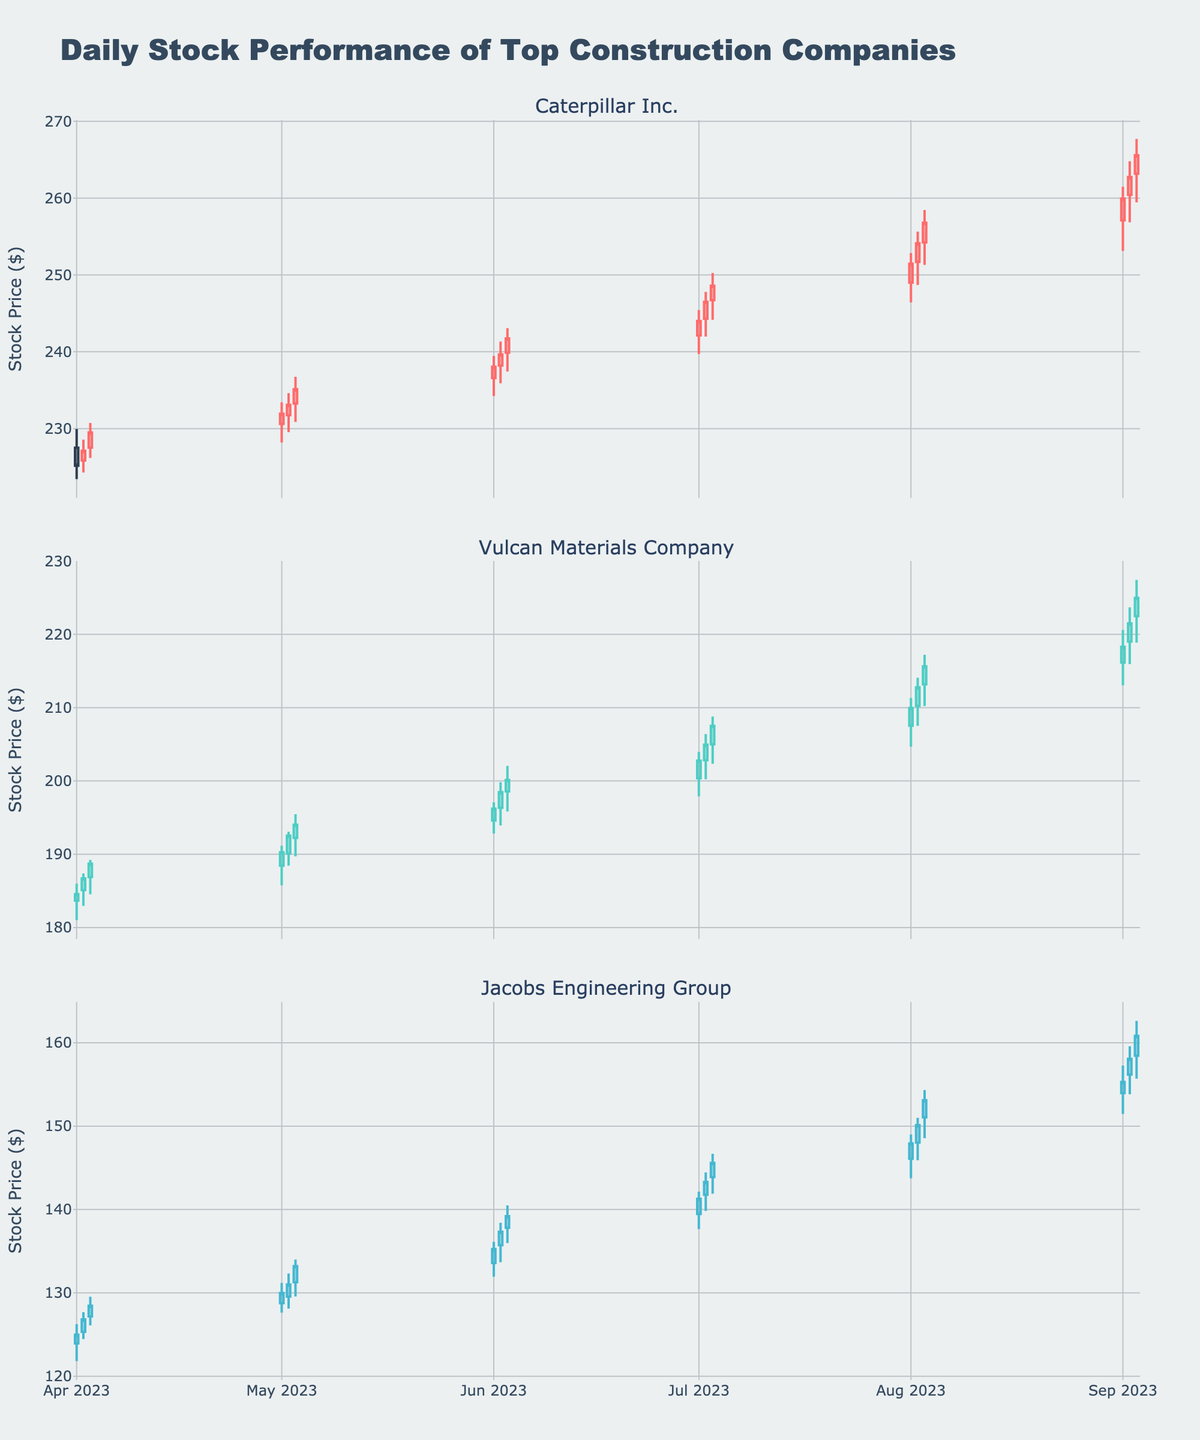Which company had the highest closing stock price on 2023-09-03? Check the closing stock prices for all companies on 2023-09-03 and compare them. Caterpillar Inc. had a closing price of 265.58, Vulcan Materials Company had a closing price of 224.98, and Jacobs Engineering Group had a closing price of 160.82.
Answer: Caterpillar Inc What is the total number of closing prices above $200 for Vulcan Materials Company? Count the candlesticks for Vulcan Materials Company where the close price is above $200. There are 6 instances (between July and September).
Answer: 6 Between which dates did Caterpillar Inc.'s stock price first surpass $250? Look at the dates where the closing price of Caterpillar Inc. first exceeds $250 and check between which dates this occurred. The stock price first closed above $250 between 2023-08-01 and 2023-08-02.
Answer: 2023-08-01 and 2023-08-02 Which company's stock had the most stable opening prices over the six-month period? Compare the range (difference between the highest and lowest) of opening prices for all companies. Jacobs Engineering Group shows the smallest range in opening prices compared to others.
Answer: Jacobs Engineering Group Calculate the average closing price for Jacobs Engineering Group in June 2023. Sum the closing prices of Jacobs Engineering Group for June 2023 and divide by the number of data points. (135.25 + 137.32 + 139.20) / 3 = 137.26
Answer: 137.26 During which month did Vulcan Materials Company see the highest increase in its closing stock price within one month? Find the difference in the closing price on the last and first trading days of each month for Vulcan. The highest increase is in August with an increase from 207.52 on 2023-07-02 to 215.64 on 2023-08-03.
Answer: August For which company did the high prices and closing prices consistently increase over the three-day period in April 2023? Examine the high and closing prices for each company during 2023-04-01 to 2023-04-03. Caterpillar Inc. shows consistently increasing high and closing prices over these three days.
Answer: Caterpillar Inc How many times did Caterpillar Inc.'s stock close lower than it opened in July 2023? Count the occasions in July when Caterpillar Inc's closing price was lower than the opening price. This happened 0 times in July 2023.
Answer: 0 